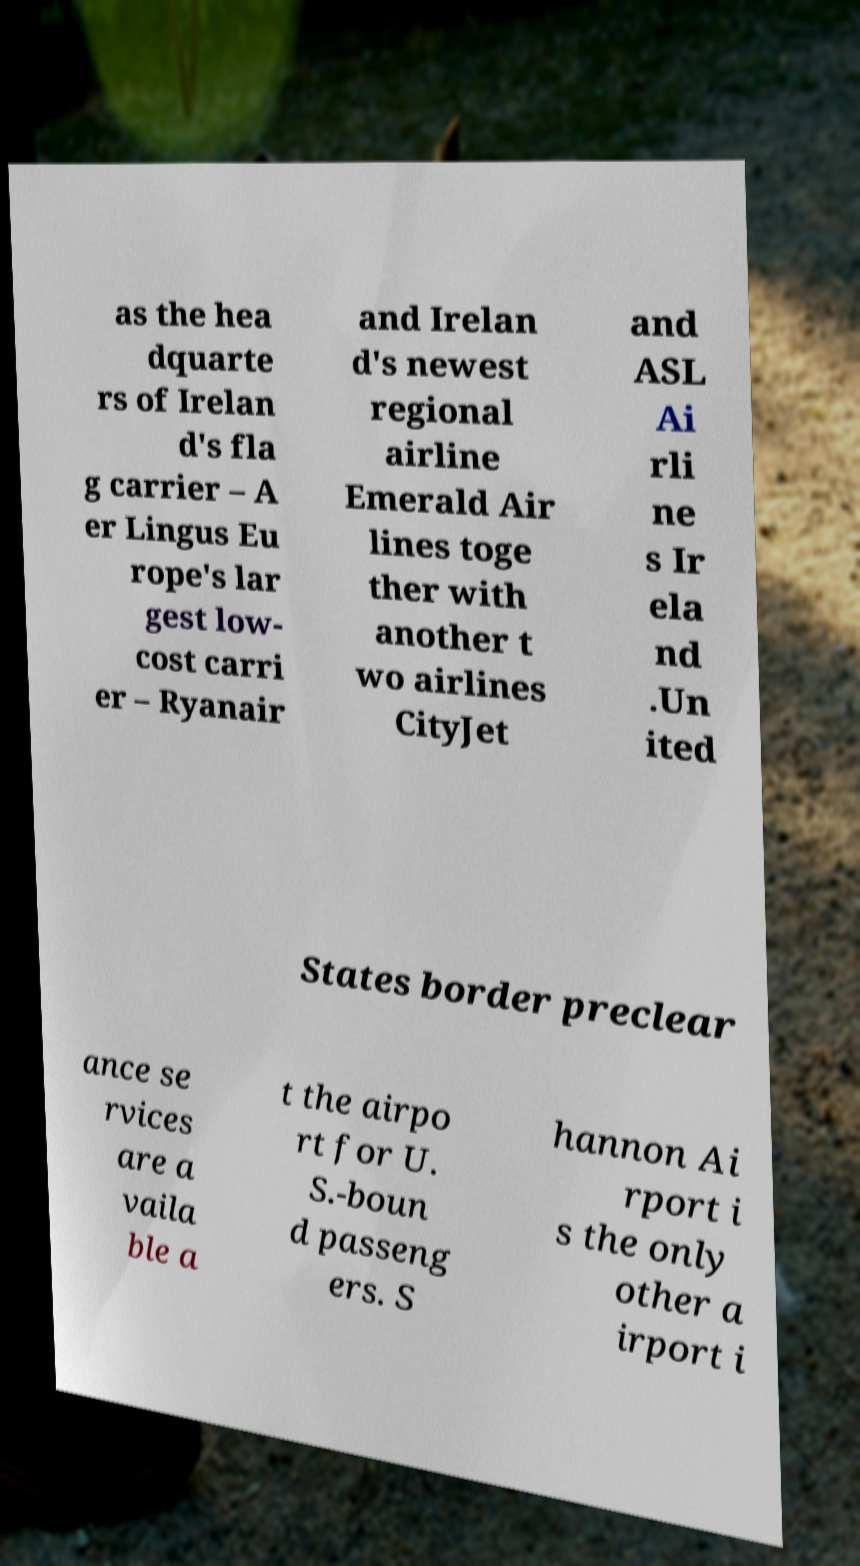Please read and relay the text visible in this image. What does it say? as the hea dquarte rs of Irelan d's fla g carrier – A er Lingus Eu rope's lar gest low- cost carri er – Ryanair and Irelan d's newest regional airline Emerald Air lines toge ther with another t wo airlines CityJet and ASL Ai rli ne s Ir ela nd .Un ited States border preclear ance se rvices are a vaila ble a t the airpo rt for U. S.-boun d passeng ers. S hannon Ai rport i s the only other a irport i 